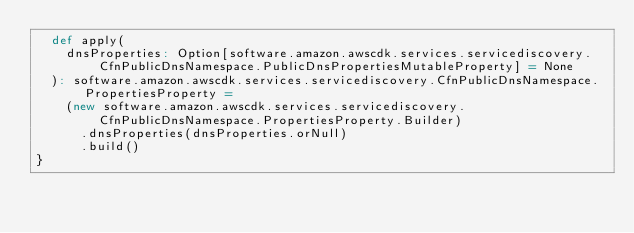Convert code to text. <code><loc_0><loc_0><loc_500><loc_500><_Scala_>  def apply(
    dnsProperties: Option[software.amazon.awscdk.services.servicediscovery.CfnPublicDnsNamespace.PublicDnsPropertiesMutableProperty] = None
  ): software.amazon.awscdk.services.servicediscovery.CfnPublicDnsNamespace.PropertiesProperty =
    (new software.amazon.awscdk.services.servicediscovery.CfnPublicDnsNamespace.PropertiesProperty.Builder)
      .dnsProperties(dnsProperties.orNull)
      .build()
}
</code> 